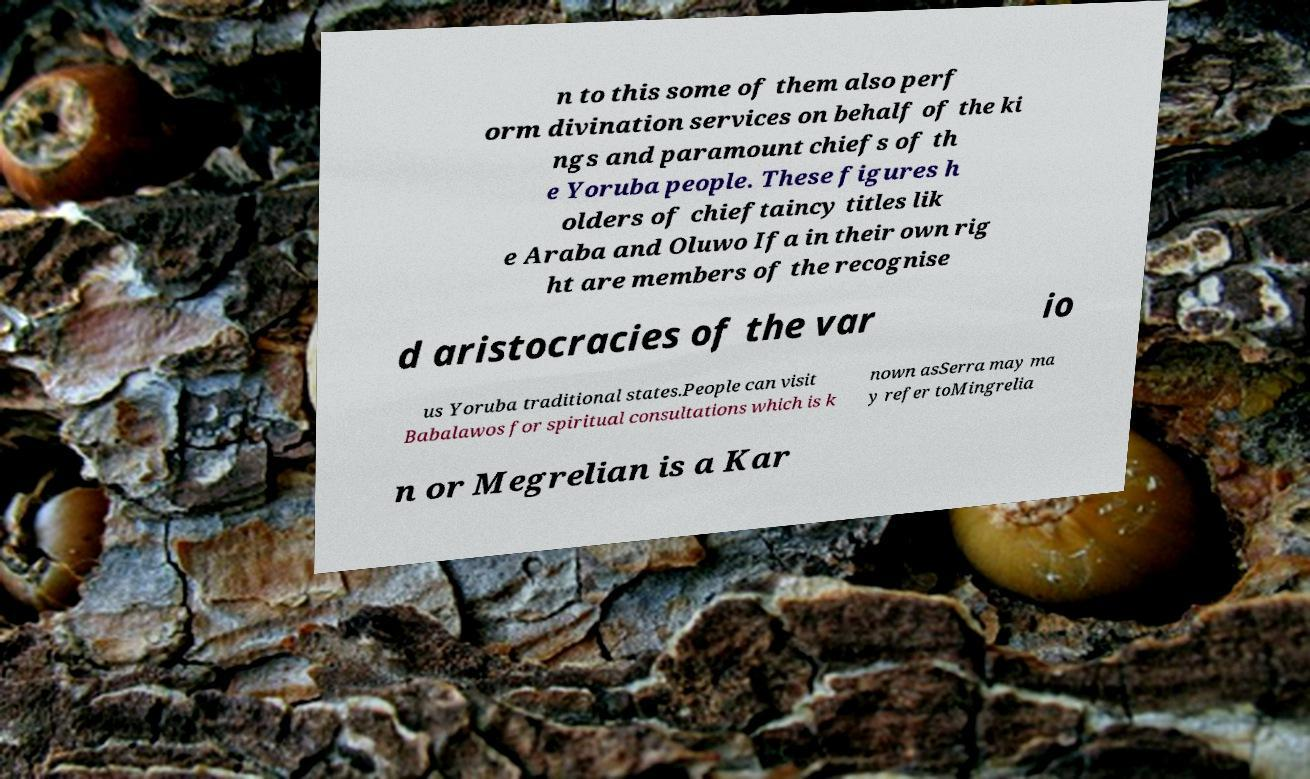Can you read and provide the text displayed in the image?This photo seems to have some interesting text. Can you extract and type it out for me? n to this some of them also perf orm divination services on behalf of the ki ngs and paramount chiefs of th e Yoruba people. These figures h olders of chieftaincy titles lik e Araba and Oluwo Ifa in their own rig ht are members of the recognise d aristocracies of the var io us Yoruba traditional states.People can visit Babalawos for spiritual consultations which is k nown asSerra may ma y refer toMingrelia n or Megrelian is a Kar 